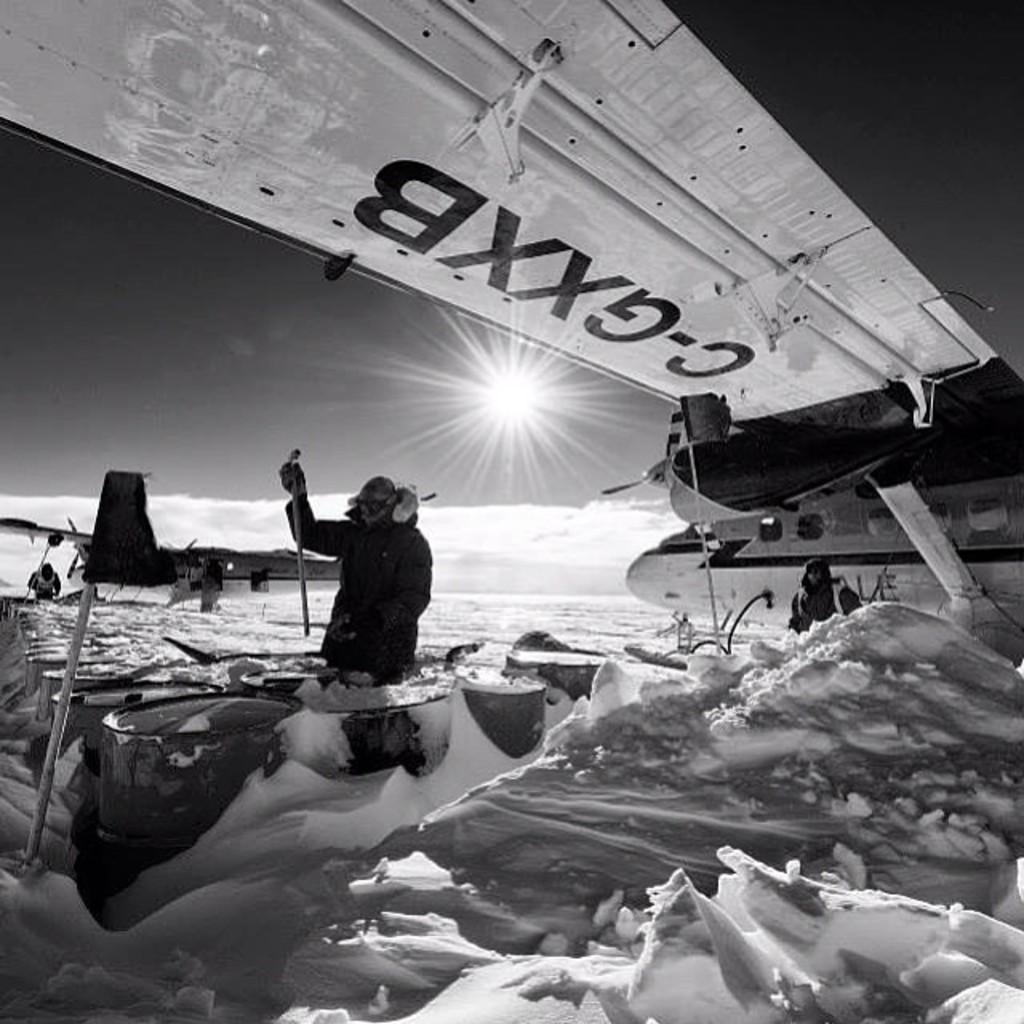<image>
Render a clear and concise summary of the photo. a man sitting under an airplane wing with the letters c-gxxb on it. 